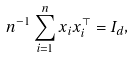Convert formula to latex. <formula><loc_0><loc_0><loc_500><loc_500>n ^ { - 1 } \sum _ { i = 1 } ^ { n } x _ { i } x _ { i } ^ { \top } = I _ { d } ,</formula> 